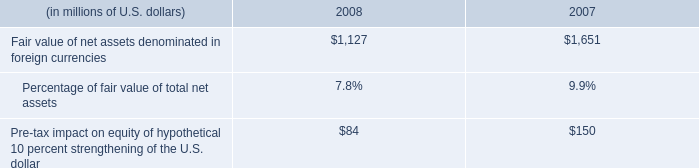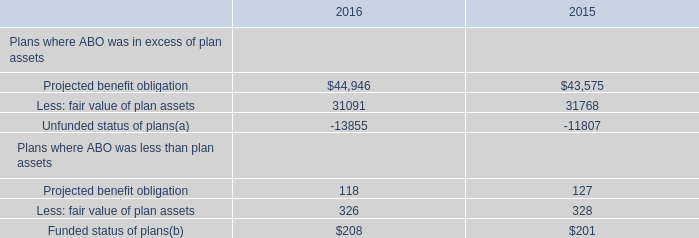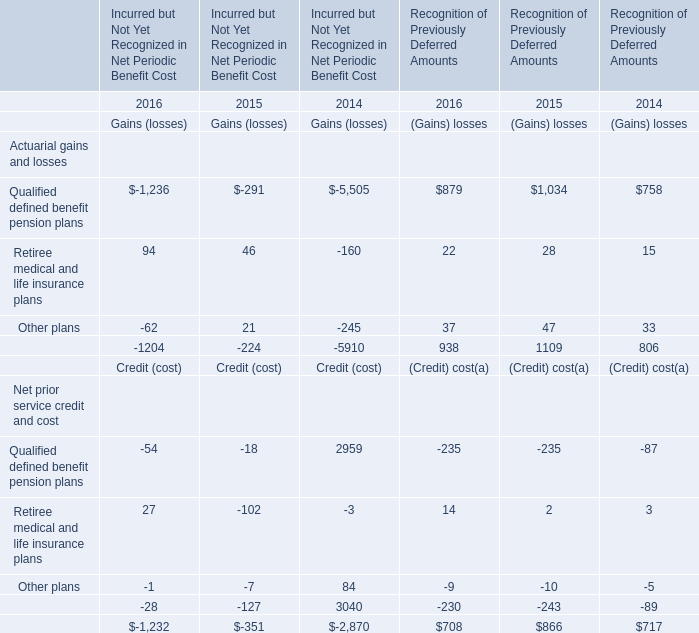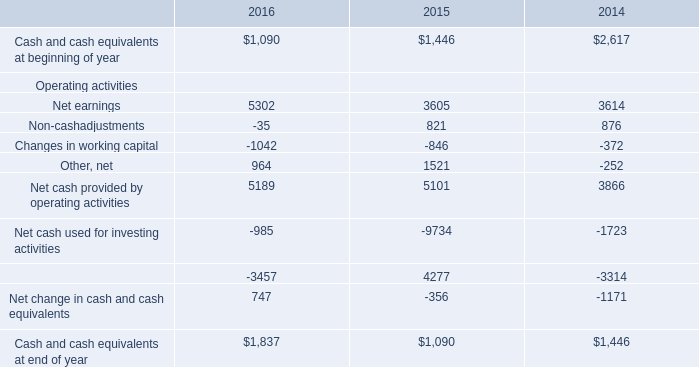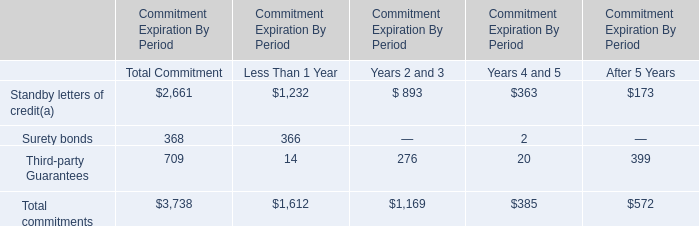what is percentage change in fair value of net assets denominated in foreign currencies from 2007 to 2008? 
Computations: ((1127 - 1651) / 1651)
Answer: -0.31738. 